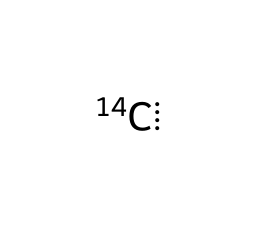What is the total number of protons in carbon-14? Carbon-14 has 6 protons, which is specific to the element carbon, regardless of the isotope.
Answer: 6 How many neutrons are present in carbon-14? Carbon-14 is an isotope of carbon with a mass number of 14. Since it has 6 protons, it has 14 - 6 = 8 neutrons.
Answer: 8 What element does carbon-14 represent? The symbol [14C] indicates that this is a carbon isotope, specifically carbon-14.
Answer: carbon What is the primary use of carbon-14 in science? Carbon-14 is widely used for dating ancient organic materials, such as archaeological artifacts, in the field of radiocarbon dating.
Answer: radiocarbon dating How does the mass number of carbon-14 compare to carbon-12? The mass number 14 for carbon-14 is greater than the mass number 12 for the more common isotope, carbon-12, by 2.
Answer: greater by 2 What type of radioactivity does carbon-14 undergo? Carbon-14 undergoes beta decay as it is an unstable isotope that decays to become nitrogen-14.
Answer: beta decay Why is carbon-14 considered to be an isotope of carbon? Carbon-14 has the same number of protons (6) as carbon-12 but a different number of neutrons (8), making it an isotope of carbon.
Answer: because of different neutrons 